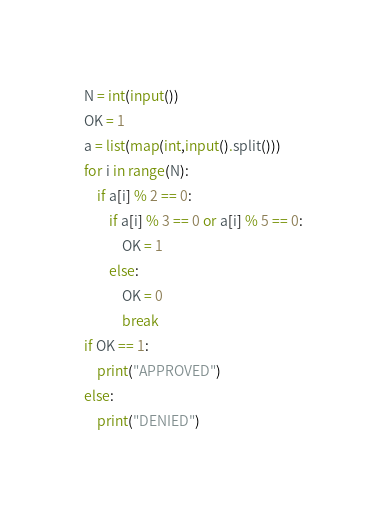Convert code to text. <code><loc_0><loc_0><loc_500><loc_500><_Python_>N = int(input())
OK = 1
a = list(map(int,input().split()))
for i in range(N):
    if a[i] % 2 == 0:
        if a[i] % 3 == 0 or a[i] % 5 == 0:
            OK = 1
        else:
            OK = 0
            break
if OK == 1:
    print("APPROVED")
else:
    print("DENIED")
</code> 